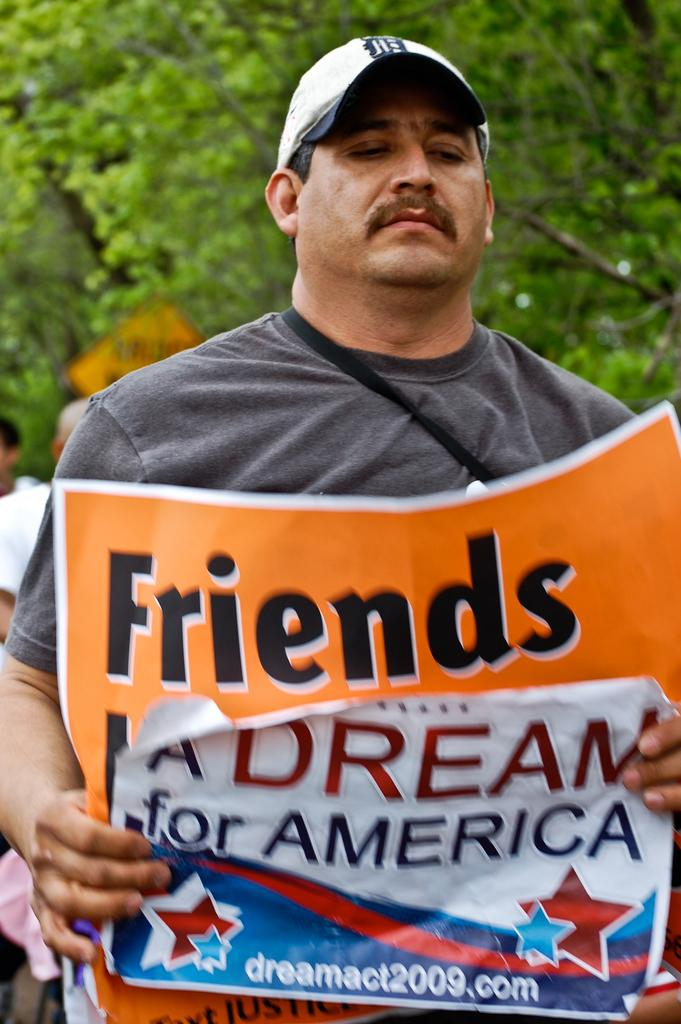<image>
Present a compact description of the photo's key features. A man holds an orange banner that says Friends on top. 